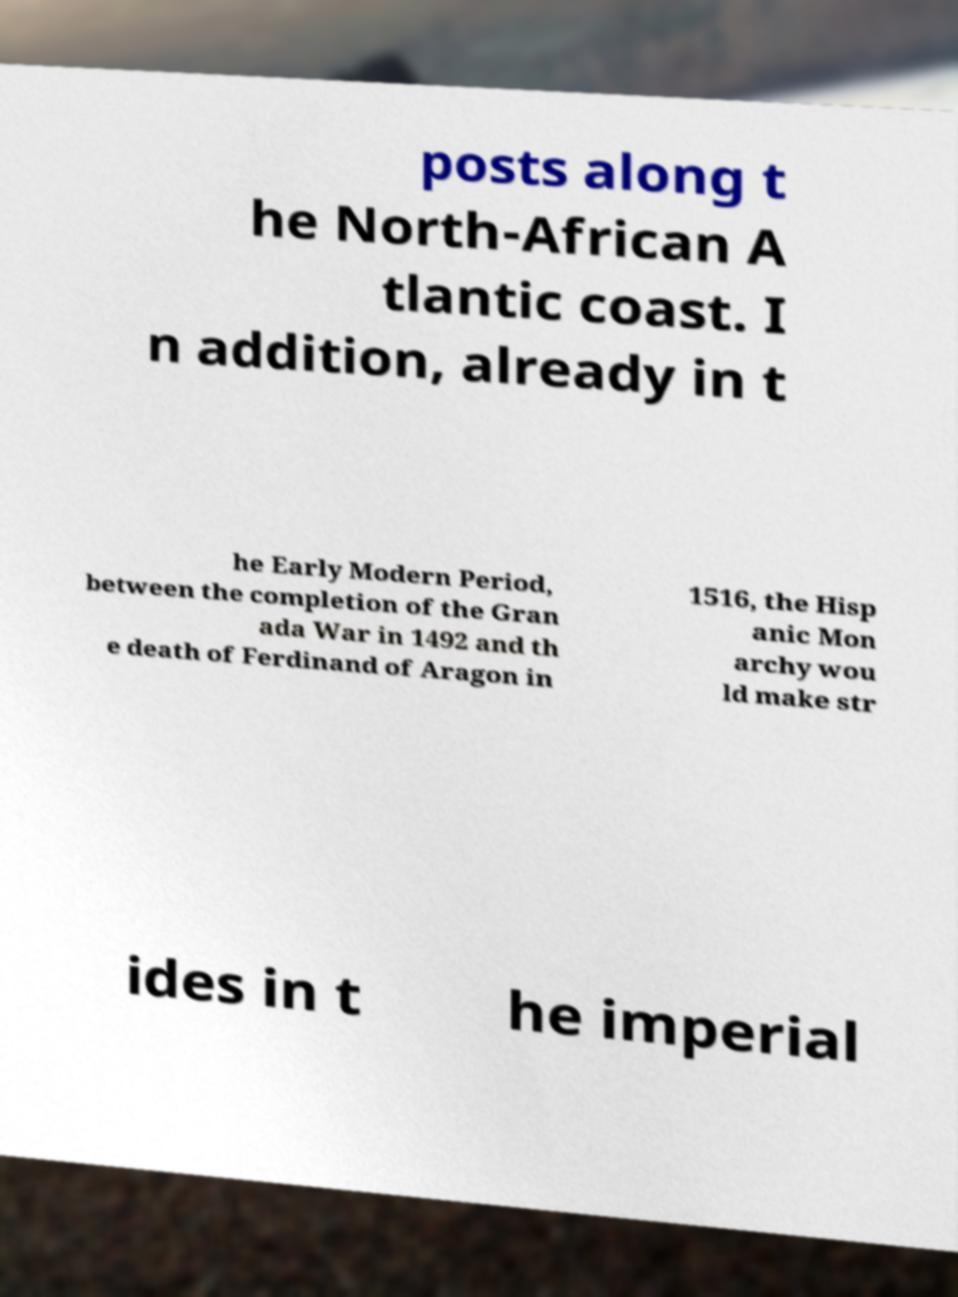For documentation purposes, I need the text within this image transcribed. Could you provide that? posts along t he North-African A tlantic coast. I n addition, already in t he Early Modern Period, between the completion of the Gran ada War in 1492 and th e death of Ferdinand of Aragon in 1516, the Hisp anic Mon archy wou ld make str ides in t he imperial 